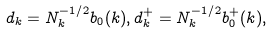<formula> <loc_0><loc_0><loc_500><loc_500>d _ { k } = N _ { k } ^ { - 1 / 2 } b _ { 0 } ( k ) , d _ { k } ^ { + } = N _ { k } ^ { - 1 / 2 } b _ { 0 } ^ { + } ( k ) ,</formula> 